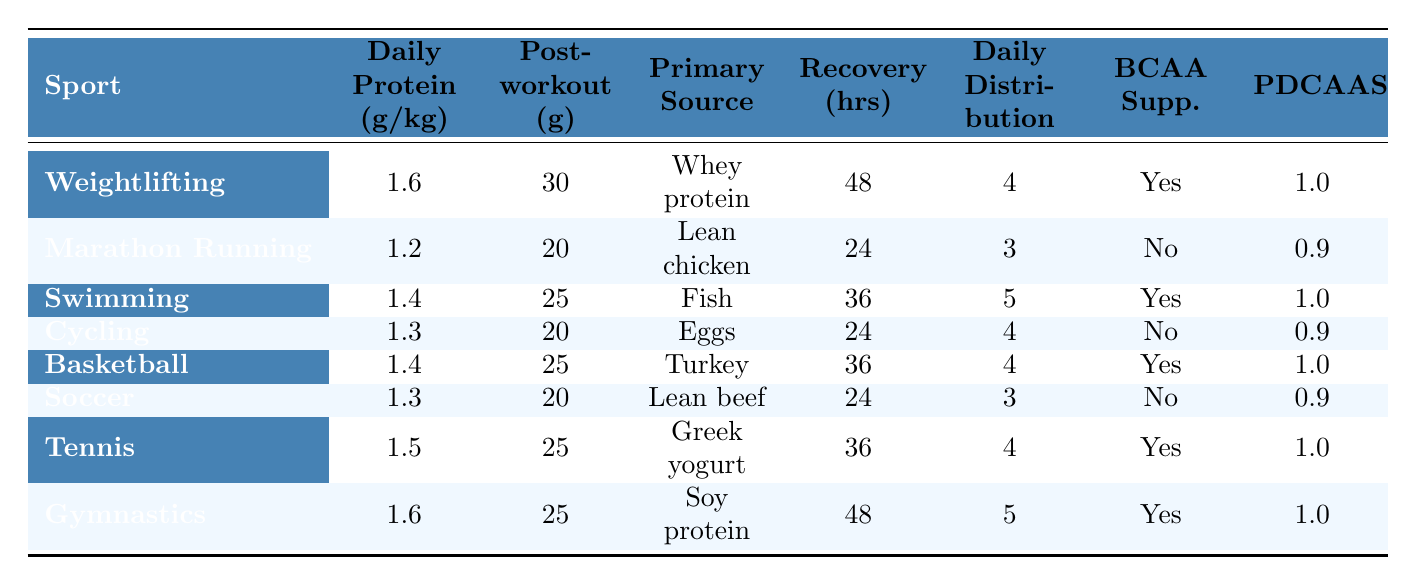What is the recommended daily protein intake for marathon runners? The table states that the recommended daily protein intake for marathon runners is 1.2 g per kg.
Answer: 1.2 g/kg Which sport has the highest post-workout protein requirement? The maximum post-workout protein requirement listed in the table is 30 g, which applies to weightlifting.
Answer: 30 g What is the primary protein source recommended for soccer players? According to the table, lean beef is the primary protein source recommended for soccer players.
Answer: Lean beef How many hours do athletes from cycling take to recover on average? The table indicates that the average muscle recovery time for cycling athletes is 24 hours.
Answer: 24 hours Is BCAA supplementation recommended for basketball players? The table shows that BCAA supplementation is marked as "Yes" for basketball players.
Answer: Yes What’s the average recovery time for sports where BCAA supplementation is recommended? The recovery times for sports with BCAA recommendation are: Swimming (36 hrs), Basketball (36 hrs), Tennis (36 hrs), and Gymnastics (48 hrs). Adding these gives a total of 156 hrs, then dividing by 4 gives an average of 39 hrs.
Answer: 39 hours Which sport has the lowest recommended daily protein intake? Marathon running has the lowest recommended daily protein intake at 1.2 g/kg according to the table.
Answer: 1.2 g/kg Which protein sources are recommended for sports that require an average recovery time of 36 hours? The sports with a 36-hour recovery time include Swimming, Basketball, and Tennis. Their recommended protein sources are Fish, Turkey, and Greek yogurt, respectively.
Answer: Fish, Turkey, Greek yogurt What is the distribution per day for protein intake for weightlifters? The table specifies that weightlifters should distribute their protein intake over 4 meals per day.
Answer: 4 Are protein quality scores consistent across all sports? The protein quality scores differ between sports, with various scores present (1.0 and 0.9). Thus, it is not consistent across all sports.
Answer: No 